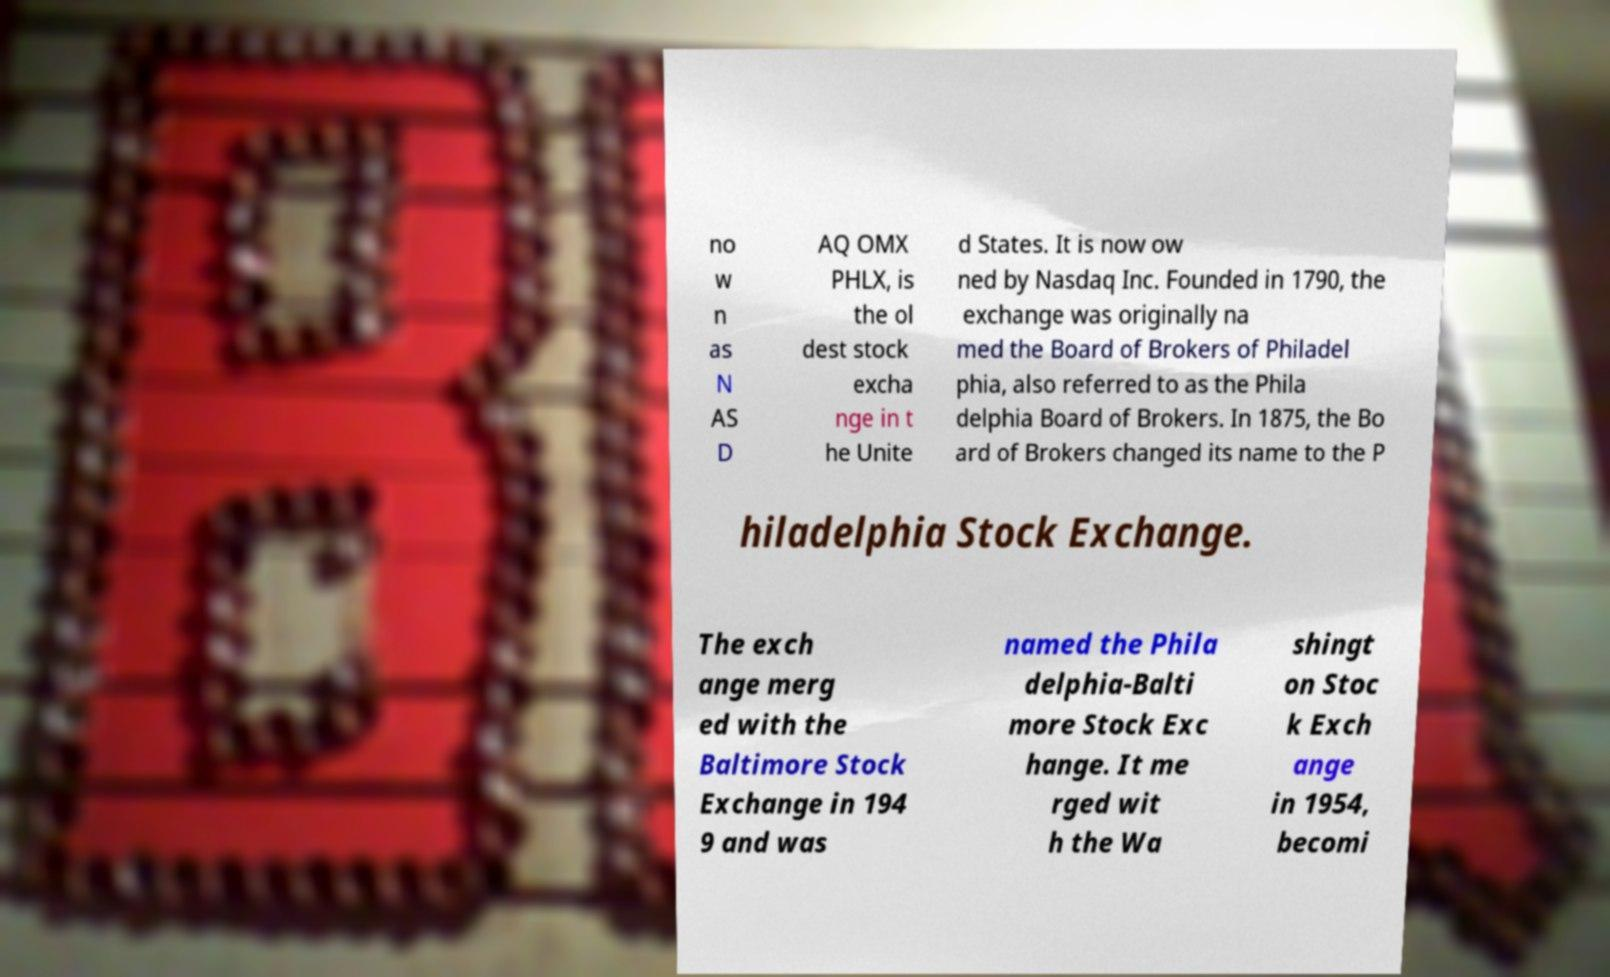For documentation purposes, I need the text within this image transcribed. Could you provide that? no w n as N AS D AQ OMX PHLX, is the ol dest stock excha nge in t he Unite d States. It is now ow ned by Nasdaq Inc. Founded in 1790, the exchange was originally na med the Board of Brokers of Philadel phia, also referred to as the Phila delphia Board of Brokers. In 1875, the Bo ard of Brokers changed its name to the P hiladelphia Stock Exchange. The exch ange merg ed with the Baltimore Stock Exchange in 194 9 and was named the Phila delphia-Balti more Stock Exc hange. It me rged wit h the Wa shingt on Stoc k Exch ange in 1954, becomi 